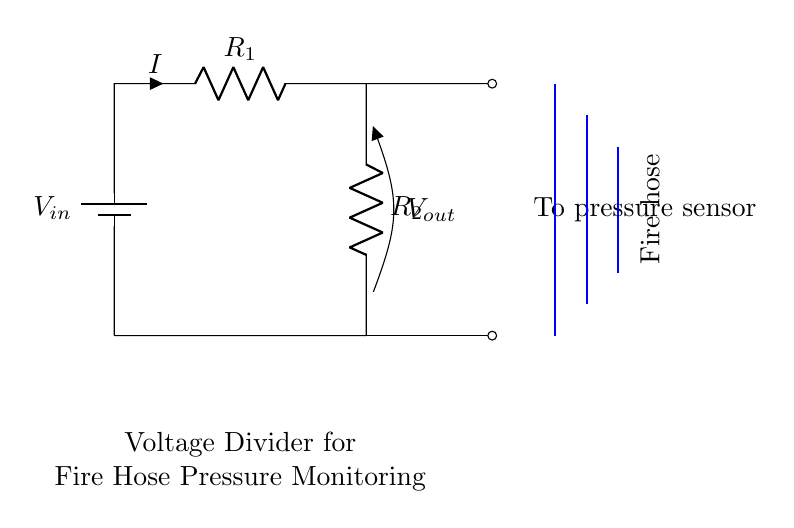What are the two resistors in the circuit? The circuit includes two resistors named R1 and R2, which are components of the voltage divider.
Answer: R1, R2 What does the output voltage depend on? The output voltage depends on the values of R1 and R2, which determine how the input voltage is divided between the two resistors.
Answer: R1, R2 What does the output voltage represent in this application? The output voltage represents the water pressure reading from the pressure sensor connected to the circuit, which monitors the pressure in the fire hose system.
Answer: Water pressure What is the role of the battery in this circuit? The battery provides the input voltage necessary for the voltage divider to function, allowing it to measure the output voltage associated with water pressure.
Answer: Input voltage How can you adjust the output voltage in this circuit? You can adjust the output voltage by changing the values of the resistors R1 and R2, which will change the division ratio of the input voltage.
Answer: Change R1, R2 What type of circuit is shown in the diagram? The diagram depicts a voltage divider circuit, commonly used to obtain a lower voltage from a higher voltage supply.
Answer: Voltage divider What happens if R2 is much smaller than R1? If R2 is much smaller than R1, the output voltage will be close to zero, indicating low pressure in the system since almost all the voltage drops across R1.
Answer: Output voltage close to zero 